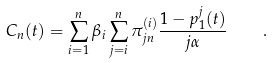Convert formula to latex. <formula><loc_0><loc_0><loc_500><loc_500>C _ { n } ( t ) = \sum _ { i = 1 } ^ { n } \beta _ { i } \sum _ { j = i } ^ { n } \pi ^ { ( i ) } _ { j n } \frac { 1 - p _ { 1 } ^ { j } ( t ) } { j \alpha } \quad .</formula> 